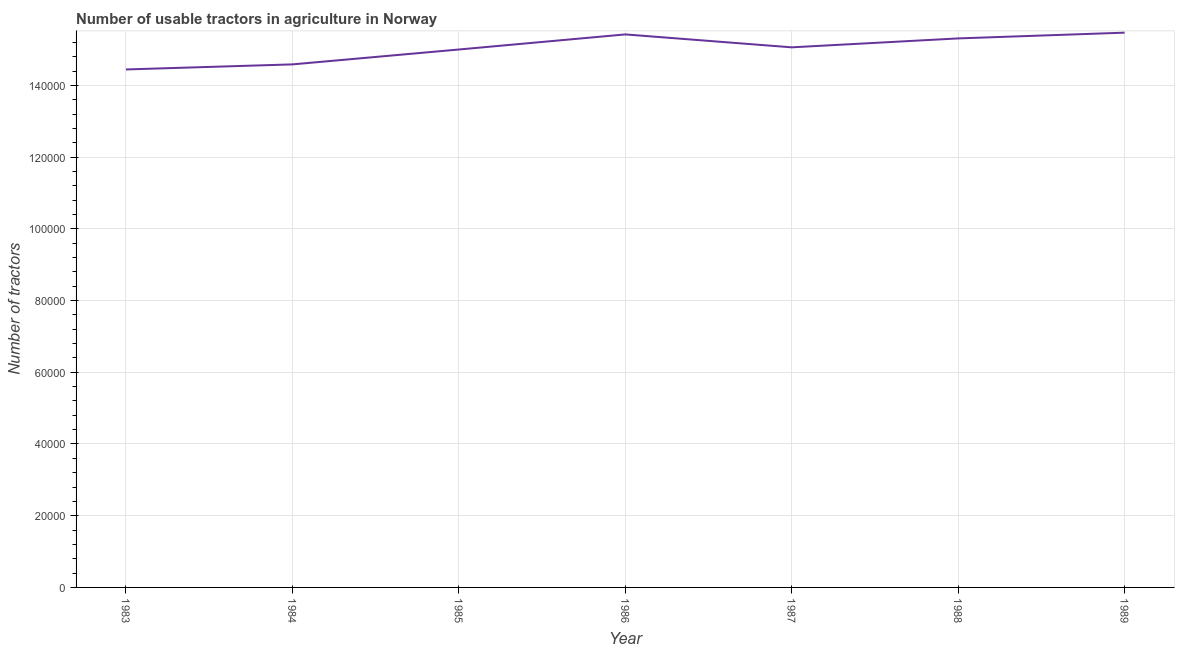What is the number of tractors in 1989?
Keep it short and to the point. 1.55e+05. Across all years, what is the maximum number of tractors?
Provide a succinct answer. 1.55e+05. Across all years, what is the minimum number of tractors?
Your response must be concise. 1.44e+05. What is the sum of the number of tractors?
Offer a very short reply. 1.05e+06. What is the difference between the number of tractors in 1984 and 1986?
Your response must be concise. -8361. What is the average number of tractors per year?
Give a very brief answer. 1.50e+05. What is the median number of tractors?
Your answer should be compact. 1.51e+05. In how many years, is the number of tractors greater than 16000 ?
Offer a very short reply. 7. Do a majority of the years between 1984 and 1983 (inclusive) have number of tractors greater than 64000 ?
Offer a terse response. No. What is the ratio of the number of tractors in 1983 to that in 1989?
Provide a succinct answer. 0.93. Is the number of tractors in 1985 less than that in 1986?
Give a very brief answer. Yes. Is the difference between the number of tractors in 1986 and 1987 greater than the difference between any two years?
Make the answer very short. No. What is the difference between the highest and the second highest number of tractors?
Provide a short and direct response. 487. Is the sum of the number of tractors in 1984 and 1987 greater than the maximum number of tractors across all years?
Offer a very short reply. Yes. What is the difference between the highest and the lowest number of tractors?
Provide a succinct answer. 1.03e+04. Does the number of tractors monotonically increase over the years?
Make the answer very short. No. How many lines are there?
Your response must be concise. 1. How many years are there in the graph?
Give a very brief answer. 7. What is the difference between two consecutive major ticks on the Y-axis?
Your response must be concise. 2.00e+04. Does the graph contain grids?
Provide a short and direct response. Yes. What is the title of the graph?
Keep it short and to the point. Number of usable tractors in agriculture in Norway. What is the label or title of the X-axis?
Offer a very short reply. Year. What is the label or title of the Y-axis?
Your answer should be compact. Number of tractors. What is the Number of tractors of 1983?
Your response must be concise. 1.44e+05. What is the Number of tractors in 1984?
Offer a very short reply. 1.46e+05. What is the Number of tractors of 1986?
Make the answer very short. 1.54e+05. What is the Number of tractors of 1987?
Make the answer very short. 1.51e+05. What is the Number of tractors of 1988?
Offer a very short reply. 1.53e+05. What is the Number of tractors in 1989?
Offer a very short reply. 1.55e+05. What is the difference between the Number of tractors in 1983 and 1984?
Ensure brevity in your answer.  -1409. What is the difference between the Number of tractors in 1983 and 1985?
Provide a succinct answer. -5561. What is the difference between the Number of tractors in 1983 and 1986?
Your answer should be compact. -9770. What is the difference between the Number of tractors in 1983 and 1987?
Ensure brevity in your answer.  -6166. What is the difference between the Number of tractors in 1983 and 1988?
Make the answer very short. -8654. What is the difference between the Number of tractors in 1983 and 1989?
Provide a succinct answer. -1.03e+04. What is the difference between the Number of tractors in 1984 and 1985?
Keep it short and to the point. -4152. What is the difference between the Number of tractors in 1984 and 1986?
Make the answer very short. -8361. What is the difference between the Number of tractors in 1984 and 1987?
Keep it short and to the point. -4757. What is the difference between the Number of tractors in 1984 and 1988?
Ensure brevity in your answer.  -7245. What is the difference between the Number of tractors in 1984 and 1989?
Provide a succinct answer. -8848. What is the difference between the Number of tractors in 1985 and 1986?
Give a very brief answer. -4209. What is the difference between the Number of tractors in 1985 and 1987?
Your answer should be compact. -605. What is the difference between the Number of tractors in 1985 and 1988?
Offer a terse response. -3093. What is the difference between the Number of tractors in 1985 and 1989?
Your answer should be compact. -4696. What is the difference between the Number of tractors in 1986 and 1987?
Provide a short and direct response. 3604. What is the difference between the Number of tractors in 1986 and 1988?
Make the answer very short. 1116. What is the difference between the Number of tractors in 1986 and 1989?
Ensure brevity in your answer.  -487. What is the difference between the Number of tractors in 1987 and 1988?
Your answer should be very brief. -2488. What is the difference between the Number of tractors in 1987 and 1989?
Your answer should be compact. -4091. What is the difference between the Number of tractors in 1988 and 1989?
Your response must be concise. -1603. What is the ratio of the Number of tractors in 1983 to that in 1986?
Offer a very short reply. 0.94. What is the ratio of the Number of tractors in 1983 to that in 1987?
Offer a very short reply. 0.96. What is the ratio of the Number of tractors in 1983 to that in 1988?
Keep it short and to the point. 0.94. What is the ratio of the Number of tractors in 1983 to that in 1989?
Your answer should be very brief. 0.93. What is the ratio of the Number of tractors in 1984 to that in 1986?
Give a very brief answer. 0.95. What is the ratio of the Number of tractors in 1984 to that in 1988?
Ensure brevity in your answer.  0.95. What is the ratio of the Number of tractors in 1984 to that in 1989?
Give a very brief answer. 0.94. What is the ratio of the Number of tractors in 1985 to that in 1986?
Ensure brevity in your answer.  0.97. What is the ratio of the Number of tractors in 1985 to that in 1987?
Provide a short and direct response. 1. What is the ratio of the Number of tractors in 1985 to that in 1988?
Your response must be concise. 0.98. What is the ratio of the Number of tractors in 1985 to that in 1989?
Make the answer very short. 0.97. What is the ratio of the Number of tractors in 1986 to that in 1987?
Offer a very short reply. 1.02. What is the ratio of the Number of tractors in 1986 to that in 1988?
Ensure brevity in your answer.  1.01. What is the ratio of the Number of tractors in 1986 to that in 1989?
Ensure brevity in your answer.  1. What is the ratio of the Number of tractors in 1987 to that in 1988?
Provide a short and direct response. 0.98. 